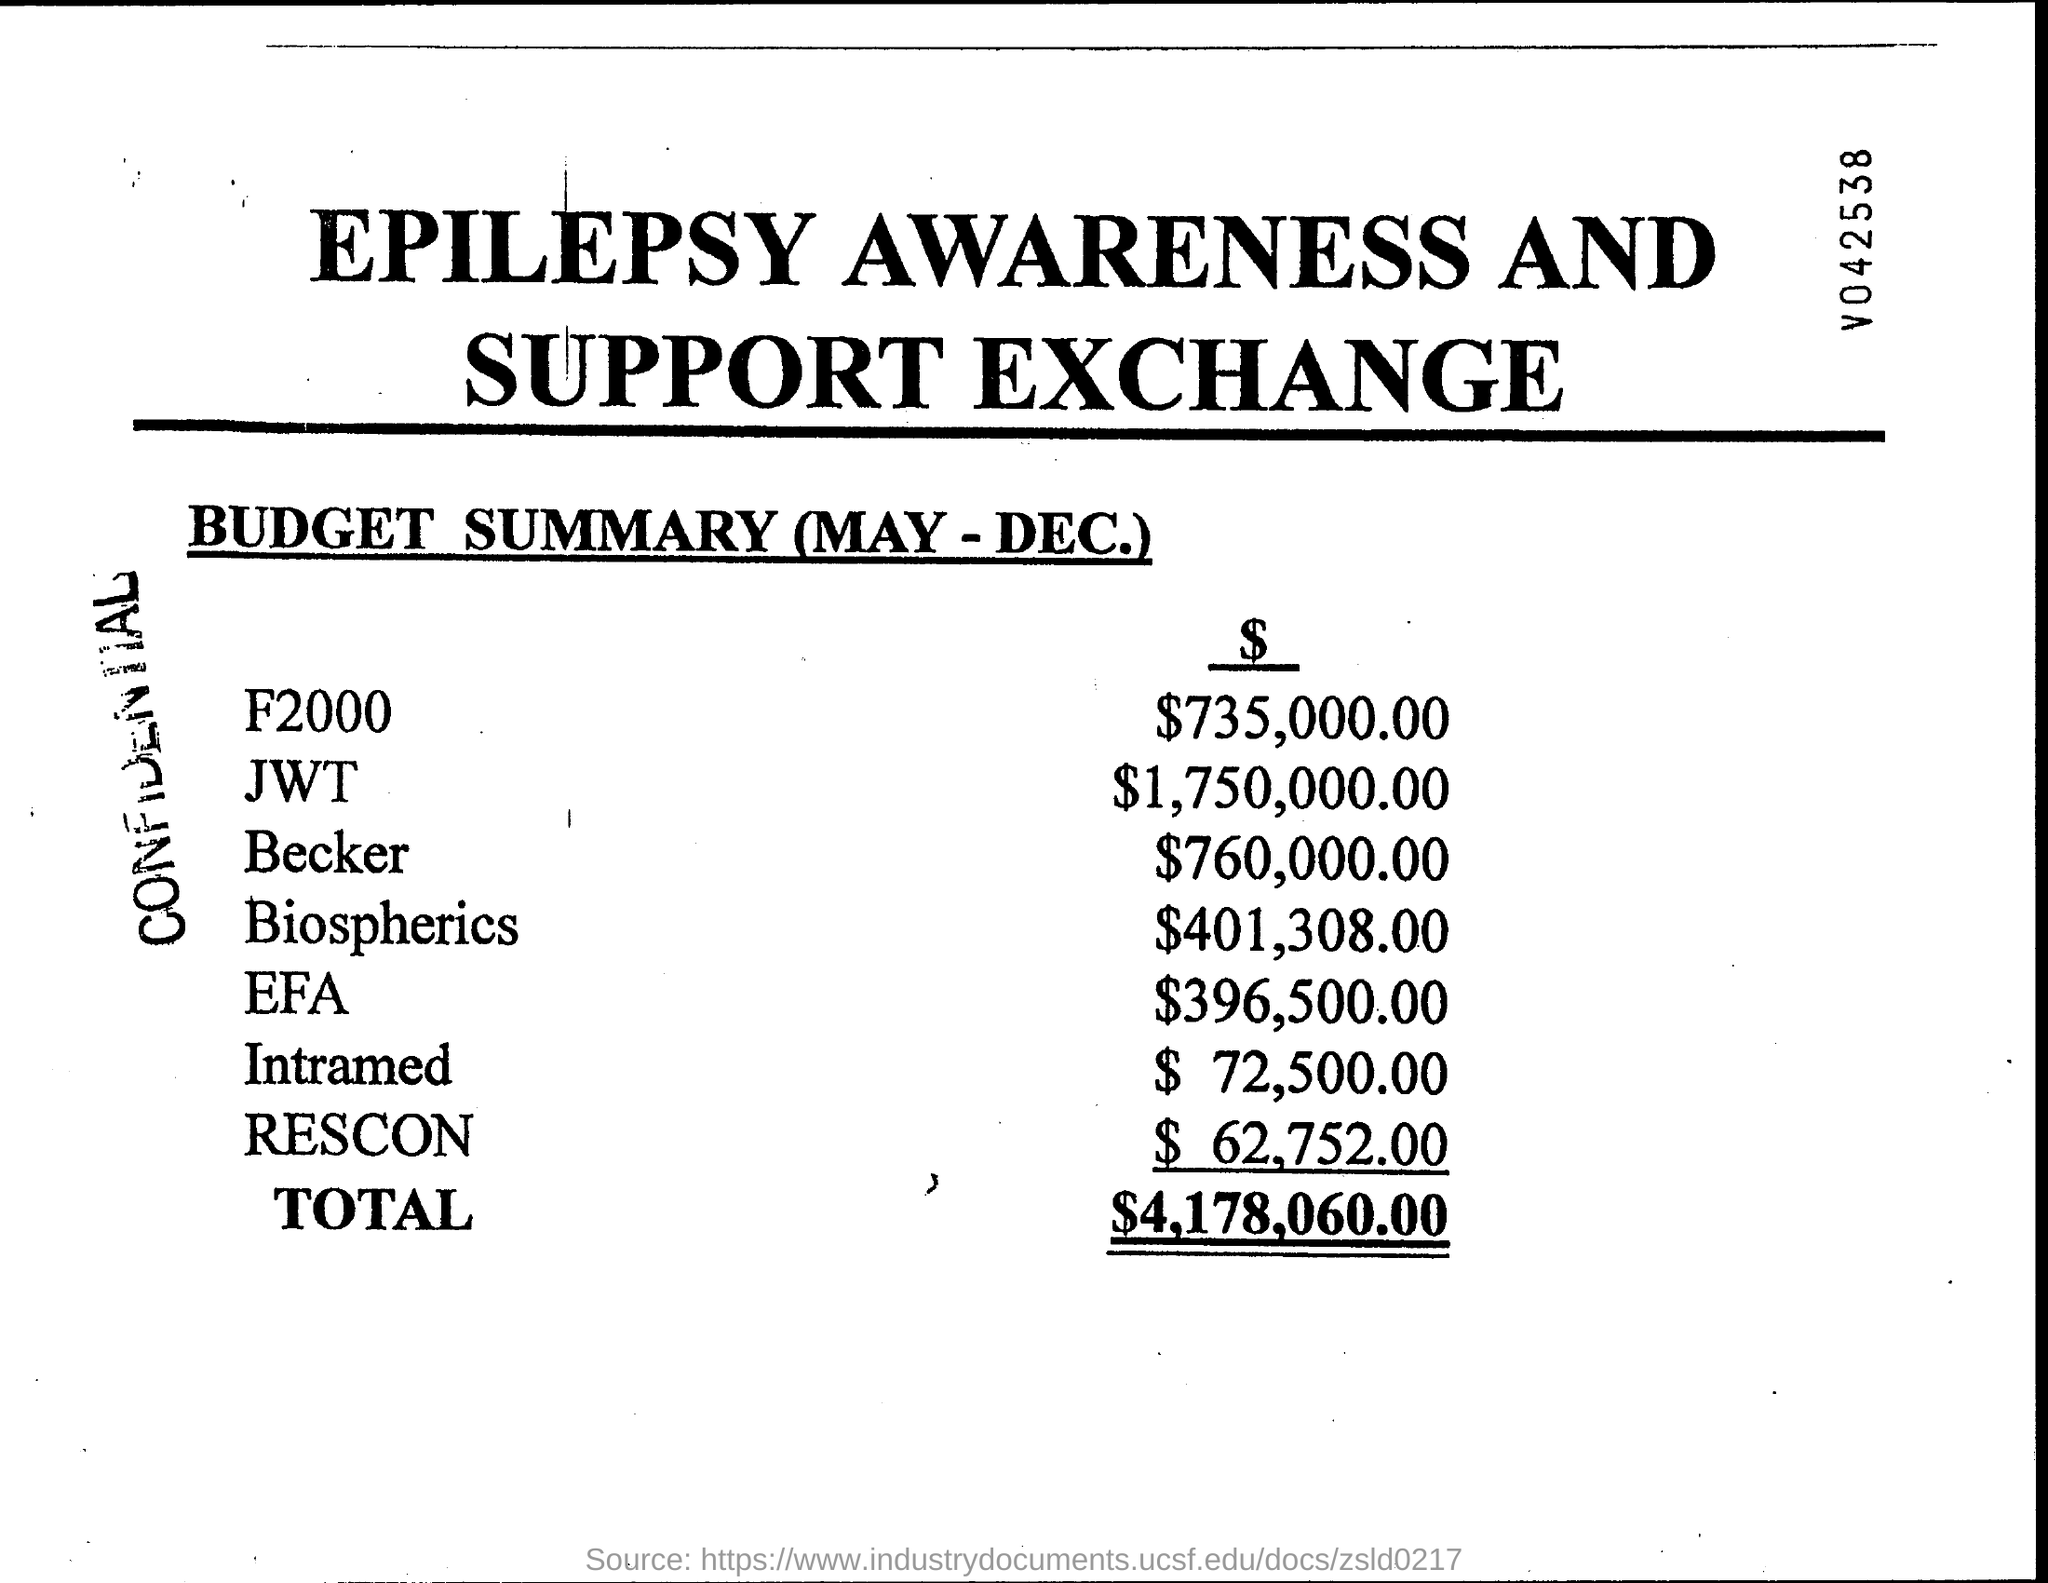What is the total of budget?
Give a very brief answer. $4,178,060.00. 